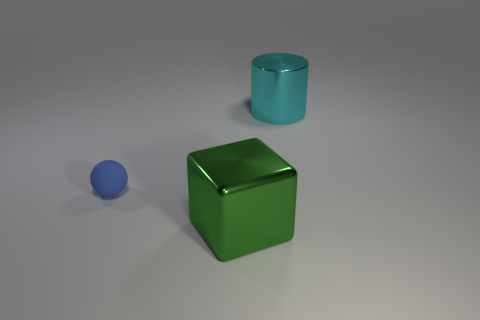Add 1 big red metal blocks. How many objects exist? 4 Subtract all cylinders. How many objects are left? 2 Add 2 big cyan cylinders. How many big cyan cylinders are left? 3 Add 2 big green blocks. How many big green blocks exist? 3 Subtract 0 green spheres. How many objects are left? 3 Subtract all tiny blue spheres. Subtract all gray rubber things. How many objects are left? 2 